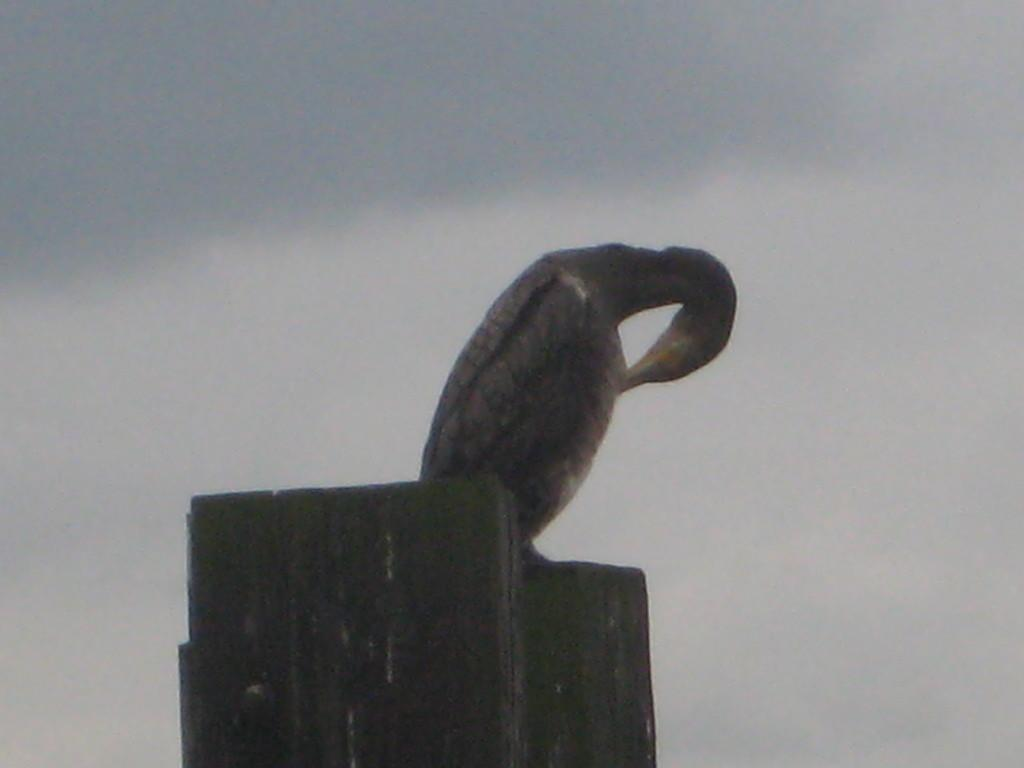What is the main subject in the foreground of the image? There is a bird in the foreground of the image. What is the bird perched on? The bird is on a wooden pole. What can be seen in the background of the image? The sky is visible in the background of the image. What is the condition of the sky in the image? There are clouds in the sky. Can you tell me how many crows are flying around the airport in the image? There is no airport or crows present in the image; it features a bird on a wooden pole with clouds in the sky. What type of club is the bird holding in the image? There is no club present in the image; the bird is perched on a wooden pole. 